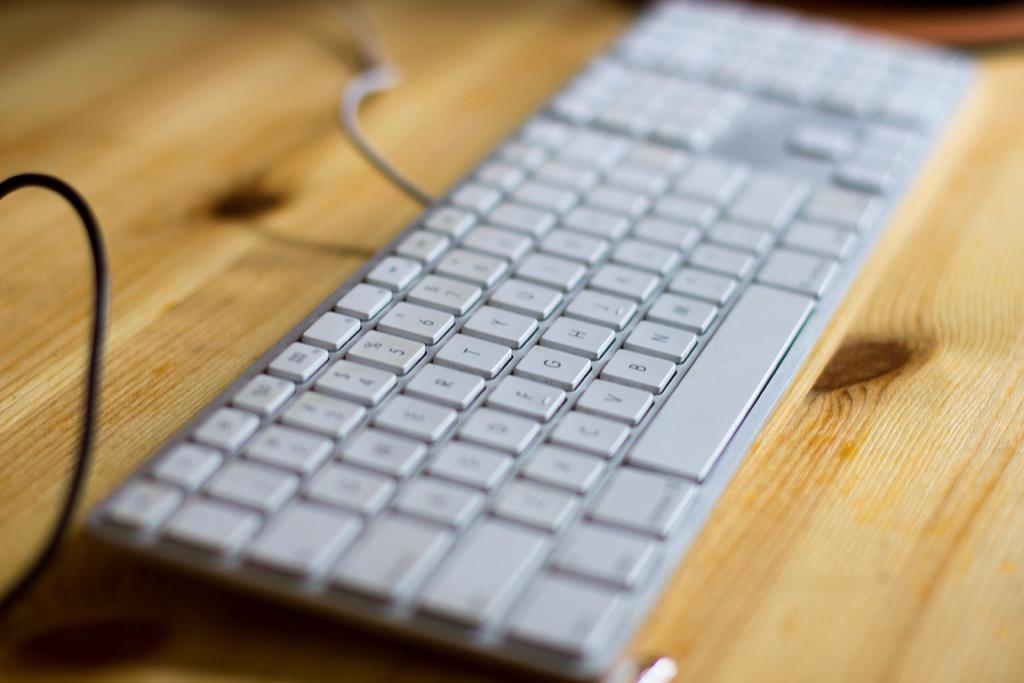<image>
Give a short and clear explanation of the subsequent image. The C key is above the top left corner of the space bar. 